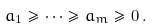Convert formula to latex. <formula><loc_0><loc_0><loc_500><loc_500>a _ { 1 } \geqslant \cdots \geqslant a _ { m } \geqslant 0 \, .</formula> 